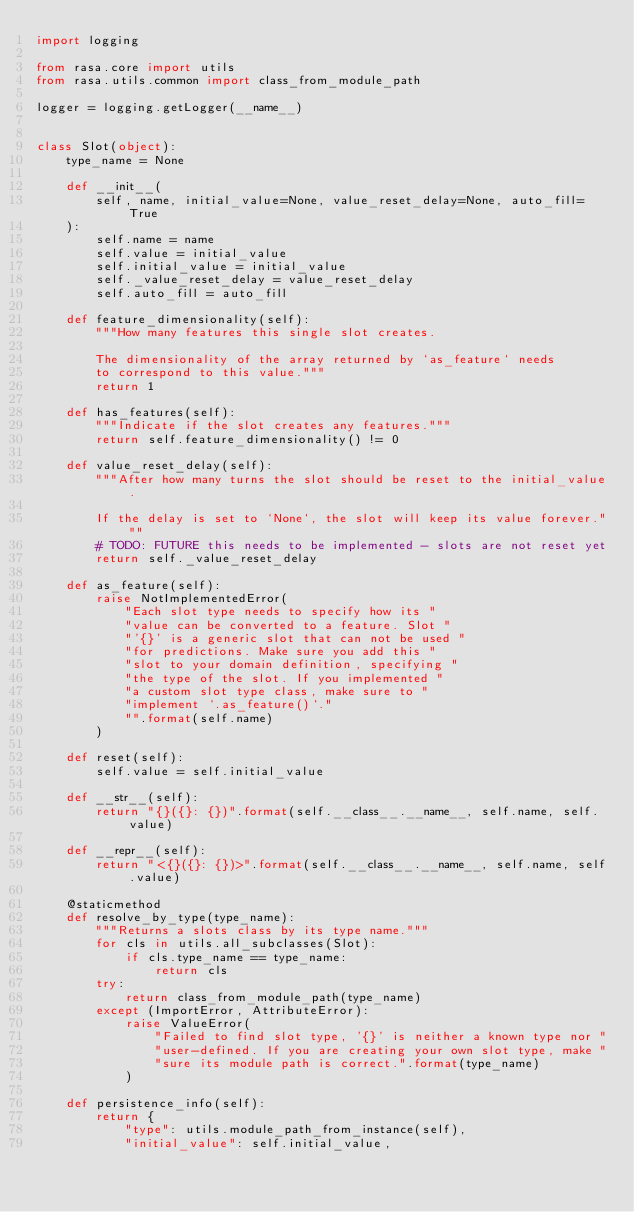<code> <loc_0><loc_0><loc_500><loc_500><_Python_>import logging

from rasa.core import utils
from rasa.utils.common import class_from_module_path

logger = logging.getLogger(__name__)


class Slot(object):
    type_name = None

    def __init__(
        self, name, initial_value=None, value_reset_delay=None, auto_fill=True
    ):
        self.name = name
        self.value = initial_value
        self.initial_value = initial_value
        self._value_reset_delay = value_reset_delay
        self.auto_fill = auto_fill

    def feature_dimensionality(self):
        """How many features this single slot creates.

        The dimensionality of the array returned by `as_feature` needs
        to correspond to this value."""
        return 1

    def has_features(self):
        """Indicate if the slot creates any features."""
        return self.feature_dimensionality() != 0

    def value_reset_delay(self):
        """After how many turns the slot should be reset to the initial_value.

        If the delay is set to `None`, the slot will keep its value forever."""
        # TODO: FUTURE this needs to be implemented - slots are not reset yet
        return self._value_reset_delay

    def as_feature(self):
        raise NotImplementedError(
            "Each slot type needs to specify how its "
            "value can be converted to a feature. Slot "
            "'{}' is a generic slot that can not be used "
            "for predictions. Make sure you add this "
            "slot to your domain definition, specifying "
            "the type of the slot. If you implemented "
            "a custom slot type class, make sure to "
            "implement `.as_feature()`."
            "".format(self.name)
        )

    def reset(self):
        self.value = self.initial_value

    def __str__(self):
        return "{}({}: {})".format(self.__class__.__name__, self.name, self.value)

    def __repr__(self):
        return "<{}({}: {})>".format(self.__class__.__name__, self.name, self.value)

    @staticmethod
    def resolve_by_type(type_name):
        """Returns a slots class by its type name."""
        for cls in utils.all_subclasses(Slot):
            if cls.type_name == type_name:
                return cls
        try:
            return class_from_module_path(type_name)
        except (ImportError, AttributeError):
            raise ValueError(
                "Failed to find slot type, '{}' is neither a known type nor "
                "user-defined. If you are creating your own slot type, make "
                "sure its module path is correct.".format(type_name)
            )

    def persistence_info(self):
        return {
            "type": utils.module_path_from_instance(self),
            "initial_value": self.initial_value,</code> 